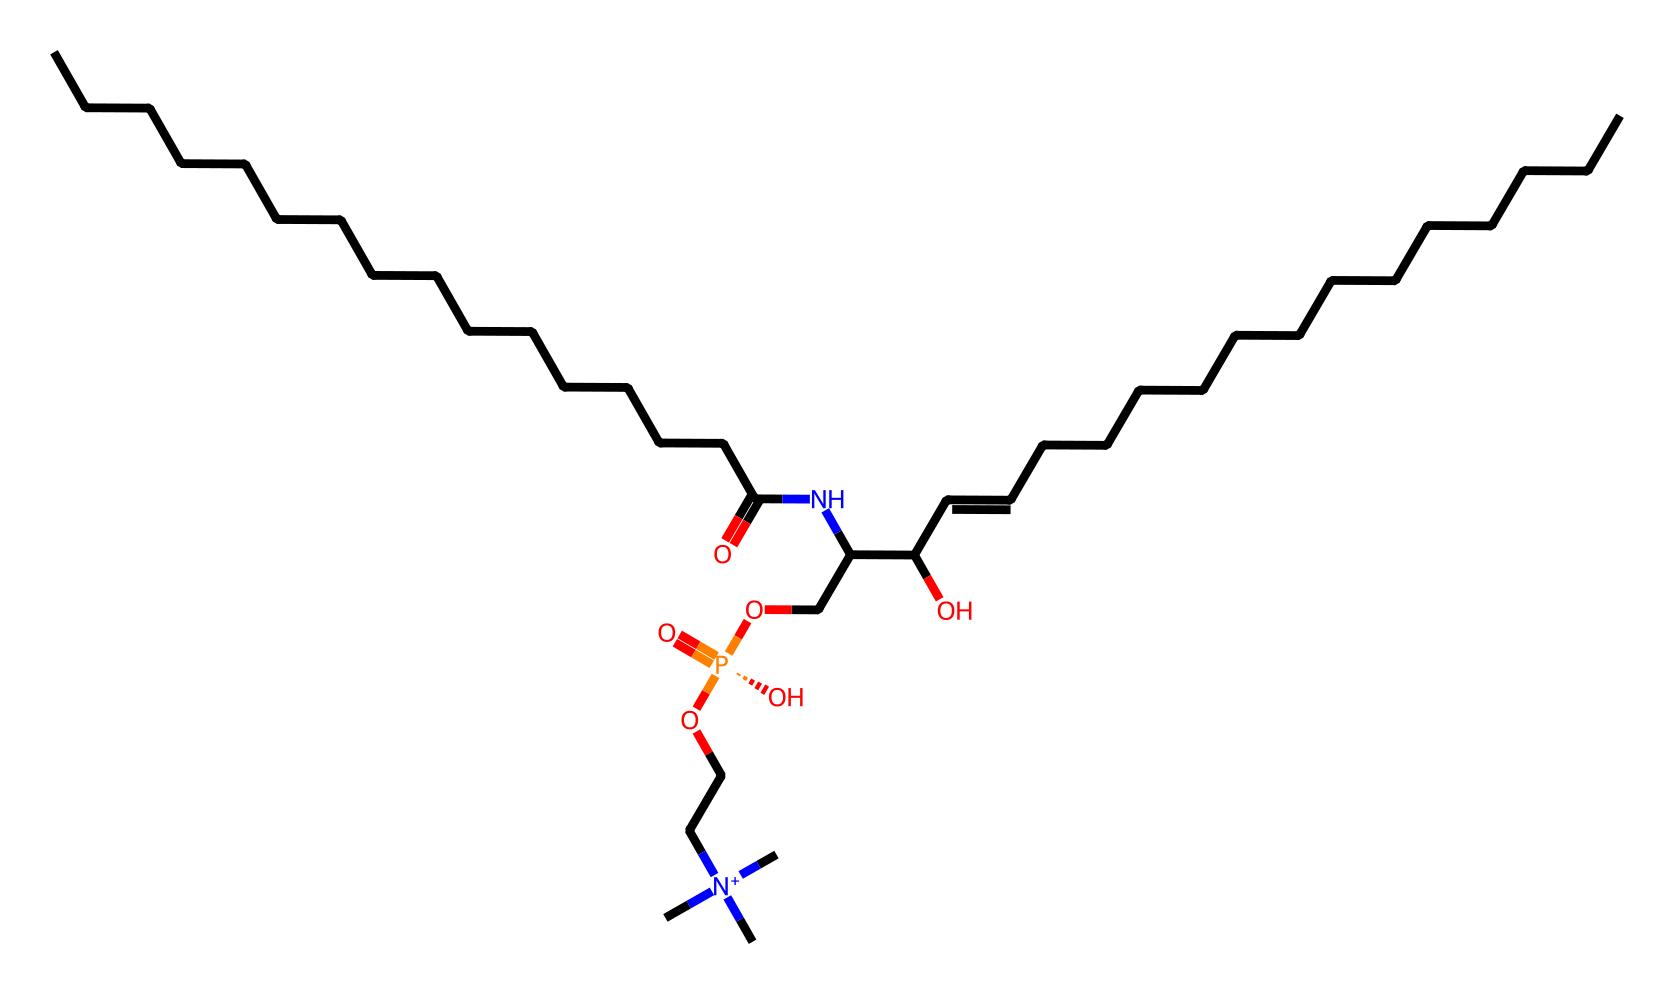What is the core functional group present in sphingomyelin? Sphingomyelin contains a sphingosine backbone, which features an amide functional group (the carbonyl and nitrogen bond).
Answer: amide How many carbon atoms are in the structure of sphingomyelin? By analyzing the SMILES representation, we count the distinct “C” symbols, resulting in 26 carbon atoms in total.
Answer: 26 What kind of lipid class does sphingomyelin belong to? Sphingomyelin is classified as a sphingolipid due to its sphingosine backbone and the presence of a fatty acid.
Answer: sphingolipid Which part of the sphingomyelin structure indicates it is a phospholipid? The presence of a phosphate group (indicated by the “[P@]” in the SMILES) attached to the molecule signifies it as a phospholipid.
Answer: phosphate group What defines the unsaturation of the fatty acid chain in this sphingomyelin structure? The 'C=C' notation in the SMILES indicates a double bond presence between two carbon atoms, defining the unsaturation.
Answer: double bond What type of nitrogen species is found in sphingomyelin? The molecule contains a quaternary ammonium nitrogen atom, as indicated by the '[N+]' in the structure, showing it is positively charged.
Answer: quaternary ammonium 